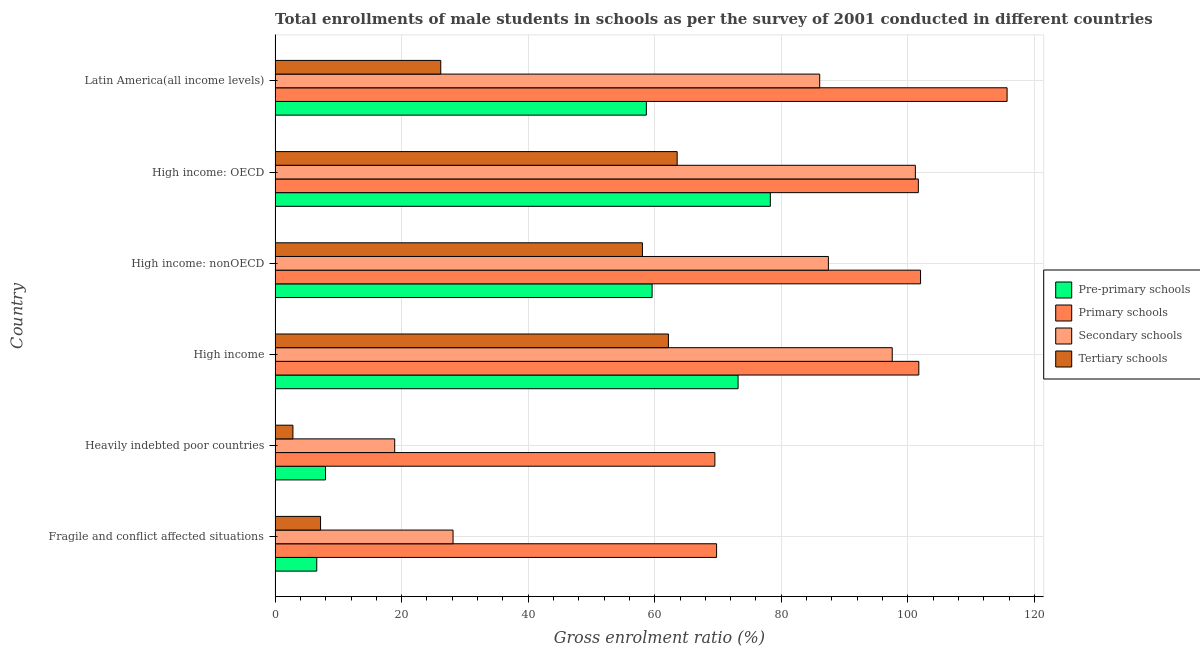How many groups of bars are there?
Provide a succinct answer. 6. Are the number of bars per tick equal to the number of legend labels?
Offer a very short reply. Yes. Are the number of bars on each tick of the Y-axis equal?
Keep it short and to the point. Yes. How many bars are there on the 5th tick from the top?
Offer a very short reply. 4. What is the label of the 5th group of bars from the top?
Keep it short and to the point. Heavily indebted poor countries. In how many cases, is the number of bars for a given country not equal to the number of legend labels?
Your response must be concise. 0. What is the gross enrolment ratio(male) in primary schools in High income?
Offer a terse response. 101.74. Across all countries, what is the maximum gross enrolment ratio(male) in secondary schools?
Give a very brief answer. 101.19. Across all countries, what is the minimum gross enrolment ratio(male) in secondary schools?
Your answer should be compact. 18.9. In which country was the gross enrolment ratio(male) in pre-primary schools maximum?
Offer a terse response. High income: OECD. In which country was the gross enrolment ratio(male) in secondary schools minimum?
Ensure brevity in your answer.  Heavily indebted poor countries. What is the total gross enrolment ratio(male) in secondary schools in the graph?
Offer a terse response. 419.28. What is the difference between the gross enrolment ratio(male) in secondary schools in Fragile and conflict affected situations and that in High income?
Keep it short and to the point. -69.41. What is the difference between the gross enrolment ratio(male) in secondary schools in High income: OECD and the gross enrolment ratio(male) in primary schools in High income: nonOECD?
Make the answer very short. -0.82. What is the average gross enrolment ratio(male) in primary schools per country?
Your answer should be compact. 93.4. What is the difference between the gross enrolment ratio(male) in pre-primary schools and gross enrolment ratio(male) in primary schools in High income: nonOECD?
Keep it short and to the point. -42.43. In how many countries, is the gross enrolment ratio(male) in pre-primary schools greater than 100 %?
Provide a succinct answer. 0. What is the ratio of the gross enrolment ratio(male) in tertiary schools in Heavily indebted poor countries to that in High income?
Your response must be concise. 0.04. What is the difference between the highest and the second highest gross enrolment ratio(male) in tertiary schools?
Make the answer very short. 1.38. What is the difference between the highest and the lowest gross enrolment ratio(male) in secondary schools?
Your answer should be compact. 82.28. In how many countries, is the gross enrolment ratio(male) in primary schools greater than the average gross enrolment ratio(male) in primary schools taken over all countries?
Your answer should be very brief. 4. Is the sum of the gross enrolment ratio(male) in pre-primary schools in High income: OECD and High income: nonOECD greater than the maximum gross enrolment ratio(male) in tertiary schools across all countries?
Provide a short and direct response. Yes. What does the 1st bar from the top in Fragile and conflict affected situations represents?
Your response must be concise. Tertiary schools. What does the 1st bar from the bottom in High income represents?
Offer a very short reply. Pre-primary schools. Is it the case that in every country, the sum of the gross enrolment ratio(male) in pre-primary schools and gross enrolment ratio(male) in primary schools is greater than the gross enrolment ratio(male) in secondary schools?
Offer a terse response. Yes. Are the values on the major ticks of X-axis written in scientific E-notation?
Ensure brevity in your answer.  No. Does the graph contain grids?
Your answer should be very brief. Yes. Where does the legend appear in the graph?
Provide a succinct answer. Center right. How many legend labels are there?
Your answer should be very brief. 4. How are the legend labels stacked?
Keep it short and to the point. Vertical. What is the title of the graph?
Offer a terse response. Total enrollments of male students in schools as per the survey of 2001 conducted in different countries. Does "Revenue mobilization" appear as one of the legend labels in the graph?
Offer a very short reply. No. What is the Gross enrolment ratio (%) of Pre-primary schools in Fragile and conflict affected situations?
Ensure brevity in your answer.  6.59. What is the Gross enrolment ratio (%) of Primary schools in Fragile and conflict affected situations?
Make the answer very short. 69.78. What is the Gross enrolment ratio (%) in Secondary schools in Fragile and conflict affected situations?
Offer a terse response. 28.13. What is the Gross enrolment ratio (%) of Tertiary schools in Fragile and conflict affected situations?
Your answer should be compact. 7.19. What is the Gross enrolment ratio (%) of Pre-primary schools in Heavily indebted poor countries?
Provide a succinct answer. 7.97. What is the Gross enrolment ratio (%) of Primary schools in Heavily indebted poor countries?
Offer a very short reply. 69.51. What is the Gross enrolment ratio (%) of Secondary schools in Heavily indebted poor countries?
Keep it short and to the point. 18.9. What is the Gross enrolment ratio (%) in Tertiary schools in Heavily indebted poor countries?
Your answer should be very brief. 2.82. What is the Gross enrolment ratio (%) in Pre-primary schools in High income?
Make the answer very short. 73.17. What is the Gross enrolment ratio (%) of Primary schools in High income?
Offer a terse response. 101.74. What is the Gross enrolment ratio (%) of Secondary schools in High income?
Your answer should be compact. 97.54. What is the Gross enrolment ratio (%) of Tertiary schools in High income?
Ensure brevity in your answer.  62.16. What is the Gross enrolment ratio (%) of Pre-primary schools in High income: nonOECD?
Offer a terse response. 59.59. What is the Gross enrolment ratio (%) in Primary schools in High income: nonOECD?
Offer a very short reply. 102.01. What is the Gross enrolment ratio (%) of Secondary schools in High income: nonOECD?
Provide a short and direct response. 87.44. What is the Gross enrolment ratio (%) of Tertiary schools in High income: nonOECD?
Your answer should be very brief. 58.06. What is the Gross enrolment ratio (%) in Pre-primary schools in High income: OECD?
Make the answer very short. 78.27. What is the Gross enrolment ratio (%) in Primary schools in High income: OECD?
Ensure brevity in your answer.  101.66. What is the Gross enrolment ratio (%) of Secondary schools in High income: OECD?
Offer a very short reply. 101.19. What is the Gross enrolment ratio (%) in Tertiary schools in High income: OECD?
Ensure brevity in your answer.  63.55. What is the Gross enrolment ratio (%) of Pre-primary schools in Latin America(all income levels)?
Your answer should be compact. 58.68. What is the Gross enrolment ratio (%) in Primary schools in Latin America(all income levels)?
Make the answer very short. 115.69. What is the Gross enrolment ratio (%) of Secondary schools in Latin America(all income levels)?
Ensure brevity in your answer.  86.07. What is the Gross enrolment ratio (%) in Tertiary schools in Latin America(all income levels)?
Your answer should be compact. 26.19. Across all countries, what is the maximum Gross enrolment ratio (%) in Pre-primary schools?
Keep it short and to the point. 78.27. Across all countries, what is the maximum Gross enrolment ratio (%) of Primary schools?
Offer a terse response. 115.69. Across all countries, what is the maximum Gross enrolment ratio (%) of Secondary schools?
Your answer should be compact. 101.19. Across all countries, what is the maximum Gross enrolment ratio (%) of Tertiary schools?
Offer a terse response. 63.55. Across all countries, what is the minimum Gross enrolment ratio (%) in Pre-primary schools?
Your response must be concise. 6.59. Across all countries, what is the minimum Gross enrolment ratio (%) in Primary schools?
Your answer should be very brief. 69.51. Across all countries, what is the minimum Gross enrolment ratio (%) of Secondary schools?
Your answer should be very brief. 18.9. Across all countries, what is the minimum Gross enrolment ratio (%) in Tertiary schools?
Provide a succinct answer. 2.82. What is the total Gross enrolment ratio (%) in Pre-primary schools in the graph?
Provide a short and direct response. 284.26. What is the total Gross enrolment ratio (%) in Primary schools in the graph?
Offer a very short reply. 560.38. What is the total Gross enrolment ratio (%) of Secondary schools in the graph?
Give a very brief answer. 419.28. What is the total Gross enrolment ratio (%) of Tertiary schools in the graph?
Offer a terse response. 219.96. What is the difference between the Gross enrolment ratio (%) of Pre-primary schools in Fragile and conflict affected situations and that in Heavily indebted poor countries?
Provide a succinct answer. -1.38. What is the difference between the Gross enrolment ratio (%) of Primary schools in Fragile and conflict affected situations and that in Heavily indebted poor countries?
Give a very brief answer. 0.27. What is the difference between the Gross enrolment ratio (%) of Secondary schools in Fragile and conflict affected situations and that in Heavily indebted poor countries?
Keep it short and to the point. 9.22. What is the difference between the Gross enrolment ratio (%) in Tertiary schools in Fragile and conflict affected situations and that in Heavily indebted poor countries?
Your answer should be very brief. 4.37. What is the difference between the Gross enrolment ratio (%) of Pre-primary schools in Fragile and conflict affected situations and that in High income?
Give a very brief answer. -66.59. What is the difference between the Gross enrolment ratio (%) in Primary schools in Fragile and conflict affected situations and that in High income?
Provide a succinct answer. -31.96. What is the difference between the Gross enrolment ratio (%) in Secondary schools in Fragile and conflict affected situations and that in High income?
Your answer should be compact. -69.41. What is the difference between the Gross enrolment ratio (%) of Tertiary schools in Fragile and conflict affected situations and that in High income?
Your response must be concise. -54.98. What is the difference between the Gross enrolment ratio (%) of Pre-primary schools in Fragile and conflict affected situations and that in High income: nonOECD?
Provide a short and direct response. -53. What is the difference between the Gross enrolment ratio (%) of Primary schools in Fragile and conflict affected situations and that in High income: nonOECD?
Keep it short and to the point. -32.24. What is the difference between the Gross enrolment ratio (%) of Secondary schools in Fragile and conflict affected situations and that in High income: nonOECD?
Give a very brief answer. -59.32. What is the difference between the Gross enrolment ratio (%) in Tertiary schools in Fragile and conflict affected situations and that in High income: nonOECD?
Ensure brevity in your answer.  -50.87. What is the difference between the Gross enrolment ratio (%) in Pre-primary schools in Fragile and conflict affected situations and that in High income: OECD?
Provide a short and direct response. -71.68. What is the difference between the Gross enrolment ratio (%) in Primary schools in Fragile and conflict affected situations and that in High income: OECD?
Your answer should be compact. -31.88. What is the difference between the Gross enrolment ratio (%) in Secondary schools in Fragile and conflict affected situations and that in High income: OECD?
Your response must be concise. -73.06. What is the difference between the Gross enrolment ratio (%) in Tertiary schools in Fragile and conflict affected situations and that in High income: OECD?
Your answer should be compact. -56.36. What is the difference between the Gross enrolment ratio (%) in Pre-primary schools in Fragile and conflict affected situations and that in Latin America(all income levels)?
Keep it short and to the point. -52.09. What is the difference between the Gross enrolment ratio (%) in Primary schools in Fragile and conflict affected situations and that in Latin America(all income levels)?
Make the answer very short. -45.91. What is the difference between the Gross enrolment ratio (%) of Secondary schools in Fragile and conflict affected situations and that in Latin America(all income levels)?
Your answer should be very brief. -57.95. What is the difference between the Gross enrolment ratio (%) in Tertiary schools in Fragile and conflict affected situations and that in Latin America(all income levels)?
Offer a very short reply. -19. What is the difference between the Gross enrolment ratio (%) of Pre-primary schools in Heavily indebted poor countries and that in High income?
Your answer should be very brief. -65.2. What is the difference between the Gross enrolment ratio (%) in Primary schools in Heavily indebted poor countries and that in High income?
Keep it short and to the point. -32.23. What is the difference between the Gross enrolment ratio (%) of Secondary schools in Heavily indebted poor countries and that in High income?
Your answer should be very brief. -78.63. What is the difference between the Gross enrolment ratio (%) of Tertiary schools in Heavily indebted poor countries and that in High income?
Give a very brief answer. -59.34. What is the difference between the Gross enrolment ratio (%) in Pre-primary schools in Heavily indebted poor countries and that in High income: nonOECD?
Make the answer very short. -51.62. What is the difference between the Gross enrolment ratio (%) in Primary schools in Heavily indebted poor countries and that in High income: nonOECD?
Ensure brevity in your answer.  -32.51. What is the difference between the Gross enrolment ratio (%) in Secondary schools in Heavily indebted poor countries and that in High income: nonOECD?
Offer a very short reply. -68.54. What is the difference between the Gross enrolment ratio (%) of Tertiary schools in Heavily indebted poor countries and that in High income: nonOECD?
Provide a succinct answer. -55.24. What is the difference between the Gross enrolment ratio (%) in Pre-primary schools in Heavily indebted poor countries and that in High income: OECD?
Ensure brevity in your answer.  -70.3. What is the difference between the Gross enrolment ratio (%) in Primary schools in Heavily indebted poor countries and that in High income: OECD?
Your response must be concise. -32.15. What is the difference between the Gross enrolment ratio (%) in Secondary schools in Heavily indebted poor countries and that in High income: OECD?
Make the answer very short. -82.28. What is the difference between the Gross enrolment ratio (%) of Tertiary schools in Heavily indebted poor countries and that in High income: OECD?
Offer a very short reply. -60.73. What is the difference between the Gross enrolment ratio (%) in Pre-primary schools in Heavily indebted poor countries and that in Latin America(all income levels)?
Provide a succinct answer. -50.71. What is the difference between the Gross enrolment ratio (%) of Primary schools in Heavily indebted poor countries and that in Latin America(all income levels)?
Your response must be concise. -46.18. What is the difference between the Gross enrolment ratio (%) of Secondary schools in Heavily indebted poor countries and that in Latin America(all income levels)?
Offer a terse response. -67.17. What is the difference between the Gross enrolment ratio (%) of Tertiary schools in Heavily indebted poor countries and that in Latin America(all income levels)?
Ensure brevity in your answer.  -23.37. What is the difference between the Gross enrolment ratio (%) in Pre-primary schools in High income and that in High income: nonOECD?
Offer a very short reply. 13.59. What is the difference between the Gross enrolment ratio (%) in Primary schools in High income and that in High income: nonOECD?
Provide a succinct answer. -0.28. What is the difference between the Gross enrolment ratio (%) of Secondary schools in High income and that in High income: nonOECD?
Keep it short and to the point. 10.09. What is the difference between the Gross enrolment ratio (%) of Tertiary schools in High income and that in High income: nonOECD?
Make the answer very short. 4.11. What is the difference between the Gross enrolment ratio (%) of Pre-primary schools in High income and that in High income: OECD?
Offer a very short reply. -5.1. What is the difference between the Gross enrolment ratio (%) of Primary schools in High income and that in High income: OECD?
Your answer should be very brief. 0.08. What is the difference between the Gross enrolment ratio (%) in Secondary schools in High income and that in High income: OECD?
Your response must be concise. -3.65. What is the difference between the Gross enrolment ratio (%) in Tertiary schools in High income and that in High income: OECD?
Your answer should be very brief. -1.38. What is the difference between the Gross enrolment ratio (%) of Pre-primary schools in High income and that in Latin America(all income levels)?
Your answer should be very brief. 14.5. What is the difference between the Gross enrolment ratio (%) of Primary schools in High income and that in Latin America(all income levels)?
Keep it short and to the point. -13.95. What is the difference between the Gross enrolment ratio (%) of Secondary schools in High income and that in Latin America(all income levels)?
Offer a very short reply. 11.46. What is the difference between the Gross enrolment ratio (%) in Tertiary schools in High income and that in Latin America(all income levels)?
Ensure brevity in your answer.  35.98. What is the difference between the Gross enrolment ratio (%) in Pre-primary schools in High income: nonOECD and that in High income: OECD?
Your answer should be very brief. -18.68. What is the difference between the Gross enrolment ratio (%) of Primary schools in High income: nonOECD and that in High income: OECD?
Keep it short and to the point. 0.35. What is the difference between the Gross enrolment ratio (%) of Secondary schools in High income: nonOECD and that in High income: OECD?
Ensure brevity in your answer.  -13.75. What is the difference between the Gross enrolment ratio (%) in Tertiary schools in High income: nonOECD and that in High income: OECD?
Give a very brief answer. -5.49. What is the difference between the Gross enrolment ratio (%) in Pre-primary schools in High income: nonOECD and that in Latin America(all income levels)?
Make the answer very short. 0.91. What is the difference between the Gross enrolment ratio (%) in Primary schools in High income: nonOECD and that in Latin America(all income levels)?
Your answer should be compact. -13.68. What is the difference between the Gross enrolment ratio (%) in Secondary schools in High income: nonOECD and that in Latin America(all income levels)?
Offer a terse response. 1.37. What is the difference between the Gross enrolment ratio (%) of Tertiary schools in High income: nonOECD and that in Latin America(all income levels)?
Offer a very short reply. 31.87. What is the difference between the Gross enrolment ratio (%) in Pre-primary schools in High income: OECD and that in Latin America(all income levels)?
Provide a succinct answer. 19.59. What is the difference between the Gross enrolment ratio (%) in Primary schools in High income: OECD and that in Latin America(all income levels)?
Provide a short and direct response. -14.03. What is the difference between the Gross enrolment ratio (%) of Secondary schools in High income: OECD and that in Latin America(all income levels)?
Give a very brief answer. 15.12. What is the difference between the Gross enrolment ratio (%) of Tertiary schools in High income: OECD and that in Latin America(all income levels)?
Keep it short and to the point. 37.36. What is the difference between the Gross enrolment ratio (%) in Pre-primary schools in Fragile and conflict affected situations and the Gross enrolment ratio (%) in Primary schools in Heavily indebted poor countries?
Offer a very short reply. -62.92. What is the difference between the Gross enrolment ratio (%) of Pre-primary schools in Fragile and conflict affected situations and the Gross enrolment ratio (%) of Secondary schools in Heavily indebted poor countries?
Ensure brevity in your answer.  -12.32. What is the difference between the Gross enrolment ratio (%) of Pre-primary schools in Fragile and conflict affected situations and the Gross enrolment ratio (%) of Tertiary schools in Heavily indebted poor countries?
Your answer should be very brief. 3.77. What is the difference between the Gross enrolment ratio (%) in Primary schools in Fragile and conflict affected situations and the Gross enrolment ratio (%) in Secondary schools in Heavily indebted poor countries?
Offer a very short reply. 50.87. What is the difference between the Gross enrolment ratio (%) of Primary schools in Fragile and conflict affected situations and the Gross enrolment ratio (%) of Tertiary schools in Heavily indebted poor countries?
Ensure brevity in your answer.  66.96. What is the difference between the Gross enrolment ratio (%) in Secondary schools in Fragile and conflict affected situations and the Gross enrolment ratio (%) in Tertiary schools in Heavily indebted poor countries?
Give a very brief answer. 25.31. What is the difference between the Gross enrolment ratio (%) in Pre-primary schools in Fragile and conflict affected situations and the Gross enrolment ratio (%) in Primary schools in High income?
Keep it short and to the point. -95.15. What is the difference between the Gross enrolment ratio (%) of Pre-primary schools in Fragile and conflict affected situations and the Gross enrolment ratio (%) of Secondary schools in High income?
Your response must be concise. -90.95. What is the difference between the Gross enrolment ratio (%) of Pre-primary schools in Fragile and conflict affected situations and the Gross enrolment ratio (%) of Tertiary schools in High income?
Your answer should be compact. -55.58. What is the difference between the Gross enrolment ratio (%) of Primary schools in Fragile and conflict affected situations and the Gross enrolment ratio (%) of Secondary schools in High income?
Offer a terse response. -27.76. What is the difference between the Gross enrolment ratio (%) in Primary schools in Fragile and conflict affected situations and the Gross enrolment ratio (%) in Tertiary schools in High income?
Offer a terse response. 7.61. What is the difference between the Gross enrolment ratio (%) of Secondary schools in Fragile and conflict affected situations and the Gross enrolment ratio (%) of Tertiary schools in High income?
Offer a very short reply. -34.04. What is the difference between the Gross enrolment ratio (%) in Pre-primary schools in Fragile and conflict affected situations and the Gross enrolment ratio (%) in Primary schools in High income: nonOECD?
Ensure brevity in your answer.  -95.43. What is the difference between the Gross enrolment ratio (%) in Pre-primary schools in Fragile and conflict affected situations and the Gross enrolment ratio (%) in Secondary schools in High income: nonOECD?
Make the answer very short. -80.86. What is the difference between the Gross enrolment ratio (%) in Pre-primary schools in Fragile and conflict affected situations and the Gross enrolment ratio (%) in Tertiary schools in High income: nonOECD?
Make the answer very short. -51.47. What is the difference between the Gross enrolment ratio (%) in Primary schools in Fragile and conflict affected situations and the Gross enrolment ratio (%) in Secondary schools in High income: nonOECD?
Give a very brief answer. -17.67. What is the difference between the Gross enrolment ratio (%) in Primary schools in Fragile and conflict affected situations and the Gross enrolment ratio (%) in Tertiary schools in High income: nonOECD?
Provide a short and direct response. 11.72. What is the difference between the Gross enrolment ratio (%) in Secondary schools in Fragile and conflict affected situations and the Gross enrolment ratio (%) in Tertiary schools in High income: nonOECD?
Ensure brevity in your answer.  -29.93. What is the difference between the Gross enrolment ratio (%) of Pre-primary schools in Fragile and conflict affected situations and the Gross enrolment ratio (%) of Primary schools in High income: OECD?
Your answer should be very brief. -95.07. What is the difference between the Gross enrolment ratio (%) of Pre-primary schools in Fragile and conflict affected situations and the Gross enrolment ratio (%) of Secondary schools in High income: OECD?
Give a very brief answer. -94.6. What is the difference between the Gross enrolment ratio (%) in Pre-primary schools in Fragile and conflict affected situations and the Gross enrolment ratio (%) in Tertiary schools in High income: OECD?
Make the answer very short. -56.96. What is the difference between the Gross enrolment ratio (%) of Primary schools in Fragile and conflict affected situations and the Gross enrolment ratio (%) of Secondary schools in High income: OECD?
Ensure brevity in your answer.  -31.41. What is the difference between the Gross enrolment ratio (%) in Primary schools in Fragile and conflict affected situations and the Gross enrolment ratio (%) in Tertiary schools in High income: OECD?
Offer a very short reply. 6.23. What is the difference between the Gross enrolment ratio (%) of Secondary schools in Fragile and conflict affected situations and the Gross enrolment ratio (%) of Tertiary schools in High income: OECD?
Keep it short and to the point. -35.42. What is the difference between the Gross enrolment ratio (%) of Pre-primary schools in Fragile and conflict affected situations and the Gross enrolment ratio (%) of Primary schools in Latin America(all income levels)?
Your answer should be very brief. -109.1. What is the difference between the Gross enrolment ratio (%) in Pre-primary schools in Fragile and conflict affected situations and the Gross enrolment ratio (%) in Secondary schools in Latin America(all income levels)?
Offer a terse response. -79.49. What is the difference between the Gross enrolment ratio (%) of Pre-primary schools in Fragile and conflict affected situations and the Gross enrolment ratio (%) of Tertiary schools in Latin America(all income levels)?
Give a very brief answer. -19.6. What is the difference between the Gross enrolment ratio (%) of Primary schools in Fragile and conflict affected situations and the Gross enrolment ratio (%) of Secondary schools in Latin America(all income levels)?
Ensure brevity in your answer.  -16.3. What is the difference between the Gross enrolment ratio (%) of Primary schools in Fragile and conflict affected situations and the Gross enrolment ratio (%) of Tertiary schools in Latin America(all income levels)?
Your answer should be compact. 43.59. What is the difference between the Gross enrolment ratio (%) in Secondary schools in Fragile and conflict affected situations and the Gross enrolment ratio (%) in Tertiary schools in Latin America(all income levels)?
Your response must be concise. 1.94. What is the difference between the Gross enrolment ratio (%) of Pre-primary schools in Heavily indebted poor countries and the Gross enrolment ratio (%) of Primary schools in High income?
Your answer should be very brief. -93.77. What is the difference between the Gross enrolment ratio (%) of Pre-primary schools in Heavily indebted poor countries and the Gross enrolment ratio (%) of Secondary schools in High income?
Your answer should be very brief. -89.57. What is the difference between the Gross enrolment ratio (%) of Pre-primary schools in Heavily indebted poor countries and the Gross enrolment ratio (%) of Tertiary schools in High income?
Your answer should be compact. -54.2. What is the difference between the Gross enrolment ratio (%) in Primary schools in Heavily indebted poor countries and the Gross enrolment ratio (%) in Secondary schools in High income?
Provide a short and direct response. -28.03. What is the difference between the Gross enrolment ratio (%) of Primary schools in Heavily indebted poor countries and the Gross enrolment ratio (%) of Tertiary schools in High income?
Make the answer very short. 7.34. What is the difference between the Gross enrolment ratio (%) in Secondary schools in Heavily indebted poor countries and the Gross enrolment ratio (%) in Tertiary schools in High income?
Offer a very short reply. -43.26. What is the difference between the Gross enrolment ratio (%) of Pre-primary schools in Heavily indebted poor countries and the Gross enrolment ratio (%) of Primary schools in High income: nonOECD?
Keep it short and to the point. -94.04. What is the difference between the Gross enrolment ratio (%) in Pre-primary schools in Heavily indebted poor countries and the Gross enrolment ratio (%) in Secondary schools in High income: nonOECD?
Your answer should be compact. -79.48. What is the difference between the Gross enrolment ratio (%) in Pre-primary schools in Heavily indebted poor countries and the Gross enrolment ratio (%) in Tertiary schools in High income: nonOECD?
Ensure brevity in your answer.  -50.09. What is the difference between the Gross enrolment ratio (%) in Primary schools in Heavily indebted poor countries and the Gross enrolment ratio (%) in Secondary schools in High income: nonOECD?
Keep it short and to the point. -17.94. What is the difference between the Gross enrolment ratio (%) in Primary schools in Heavily indebted poor countries and the Gross enrolment ratio (%) in Tertiary schools in High income: nonOECD?
Your response must be concise. 11.45. What is the difference between the Gross enrolment ratio (%) of Secondary schools in Heavily indebted poor countries and the Gross enrolment ratio (%) of Tertiary schools in High income: nonOECD?
Your answer should be compact. -39.15. What is the difference between the Gross enrolment ratio (%) of Pre-primary schools in Heavily indebted poor countries and the Gross enrolment ratio (%) of Primary schools in High income: OECD?
Your answer should be compact. -93.69. What is the difference between the Gross enrolment ratio (%) of Pre-primary schools in Heavily indebted poor countries and the Gross enrolment ratio (%) of Secondary schools in High income: OECD?
Ensure brevity in your answer.  -93.22. What is the difference between the Gross enrolment ratio (%) in Pre-primary schools in Heavily indebted poor countries and the Gross enrolment ratio (%) in Tertiary schools in High income: OECD?
Offer a very short reply. -55.58. What is the difference between the Gross enrolment ratio (%) in Primary schools in Heavily indebted poor countries and the Gross enrolment ratio (%) in Secondary schools in High income: OECD?
Keep it short and to the point. -31.68. What is the difference between the Gross enrolment ratio (%) in Primary schools in Heavily indebted poor countries and the Gross enrolment ratio (%) in Tertiary schools in High income: OECD?
Make the answer very short. 5.96. What is the difference between the Gross enrolment ratio (%) of Secondary schools in Heavily indebted poor countries and the Gross enrolment ratio (%) of Tertiary schools in High income: OECD?
Ensure brevity in your answer.  -44.64. What is the difference between the Gross enrolment ratio (%) of Pre-primary schools in Heavily indebted poor countries and the Gross enrolment ratio (%) of Primary schools in Latin America(all income levels)?
Your response must be concise. -107.72. What is the difference between the Gross enrolment ratio (%) in Pre-primary schools in Heavily indebted poor countries and the Gross enrolment ratio (%) in Secondary schools in Latin America(all income levels)?
Provide a succinct answer. -78.11. What is the difference between the Gross enrolment ratio (%) in Pre-primary schools in Heavily indebted poor countries and the Gross enrolment ratio (%) in Tertiary schools in Latin America(all income levels)?
Provide a succinct answer. -18.22. What is the difference between the Gross enrolment ratio (%) in Primary schools in Heavily indebted poor countries and the Gross enrolment ratio (%) in Secondary schools in Latin America(all income levels)?
Give a very brief answer. -16.57. What is the difference between the Gross enrolment ratio (%) of Primary schools in Heavily indebted poor countries and the Gross enrolment ratio (%) of Tertiary schools in Latin America(all income levels)?
Offer a very short reply. 43.32. What is the difference between the Gross enrolment ratio (%) of Secondary schools in Heavily indebted poor countries and the Gross enrolment ratio (%) of Tertiary schools in Latin America(all income levels)?
Make the answer very short. -7.28. What is the difference between the Gross enrolment ratio (%) in Pre-primary schools in High income and the Gross enrolment ratio (%) in Primary schools in High income: nonOECD?
Your answer should be compact. -28.84. What is the difference between the Gross enrolment ratio (%) in Pre-primary schools in High income and the Gross enrolment ratio (%) in Secondary schools in High income: nonOECD?
Your answer should be very brief. -14.27. What is the difference between the Gross enrolment ratio (%) in Pre-primary schools in High income and the Gross enrolment ratio (%) in Tertiary schools in High income: nonOECD?
Offer a very short reply. 15.12. What is the difference between the Gross enrolment ratio (%) in Primary schools in High income and the Gross enrolment ratio (%) in Secondary schools in High income: nonOECD?
Provide a succinct answer. 14.29. What is the difference between the Gross enrolment ratio (%) of Primary schools in High income and the Gross enrolment ratio (%) of Tertiary schools in High income: nonOECD?
Your response must be concise. 43.68. What is the difference between the Gross enrolment ratio (%) in Secondary schools in High income and the Gross enrolment ratio (%) in Tertiary schools in High income: nonOECD?
Provide a succinct answer. 39.48. What is the difference between the Gross enrolment ratio (%) in Pre-primary schools in High income and the Gross enrolment ratio (%) in Primary schools in High income: OECD?
Provide a succinct answer. -28.49. What is the difference between the Gross enrolment ratio (%) in Pre-primary schools in High income and the Gross enrolment ratio (%) in Secondary schools in High income: OECD?
Provide a succinct answer. -28.02. What is the difference between the Gross enrolment ratio (%) in Pre-primary schools in High income and the Gross enrolment ratio (%) in Tertiary schools in High income: OECD?
Offer a terse response. 9.62. What is the difference between the Gross enrolment ratio (%) of Primary schools in High income and the Gross enrolment ratio (%) of Secondary schools in High income: OECD?
Your answer should be compact. 0.55. What is the difference between the Gross enrolment ratio (%) in Primary schools in High income and the Gross enrolment ratio (%) in Tertiary schools in High income: OECD?
Make the answer very short. 38.19. What is the difference between the Gross enrolment ratio (%) in Secondary schools in High income and the Gross enrolment ratio (%) in Tertiary schools in High income: OECD?
Ensure brevity in your answer.  33.99. What is the difference between the Gross enrolment ratio (%) in Pre-primary schools in High income and the Gross enrolment ratio (%) in Primary schools in Latin America(all income levels)?
Offer a terse response. -42.52. What is the difference between the Gross enrolment ratio (%) of Pre-primary schools in High income and the Gross enrolment ratio (%) of Secondary schools in Latin America(all income levels)?
Your answer should be compact. -12.9. What is the difference between the Gross enrolment ratio (%) in Pre-primary schools in High income and the Gross enrolment ratio (%) in Tertiary schools in Latin America(all income levels)?
Make the answer very short. 46.99. What is the difference between the Gross enrolment ratio (%) in Primary schools in High income and the Gross enrolment ratio (%) in Secondary schools in Latin America(all income levels)?
Keep it short and to the point. 15.66. What is the difference between the Gross enrolment ratio (%) in Primary schools in High income and the Gross enrolment ratio (%) in Tertiary schools in Latin America(all income levels)?
Your answer should be very brief. 75.55. What is the difference between the Gross enrolment ratio (%) in Secondary schools in High income and the Gross enrolment ratio (%) in Tertiary schools in Latin America(all income levels)?
Give a very brief answer. 71.35. What is the difference between the Gross enrolment ratio (%) in Pre-primary schools in High income: nonOECD and the Gross enrolment ratio (%) in Primary schools in High income: OECD?
Offer a very short reply. -42.07. What is the difference between the Gross enrolment ratio (%) of Pre-primary schools in High income: nonOECD and the Gross enrolment ratio (%) of Secondary schools in High income: OECD?
Your response must be concise. -41.6. What is the difference between the Gross enrolment ratio (%) of Pre-primary schools in High income: nonOECD and the Gross enrolment ratio (%) of Tertiary schools in High income: OECD?
Offer a terse response. -3.96. What is the difference between the Gross enrolment ratio (%) in Primary schools in High income: nonOECD and the Gross enrolment ratio (%) in Secondary schools in High income: OECD?
Give a very brief answer. 0.82. What is the difference between the Gross enrolment ratio (%) of Primary schools in High income: nonOECD and the Gross enrolment ratio (%) of Tertiary schools in High income: OECD?
Your answer should be compact. 38.46. What is the difference between the Gross enrolment ratio (%) of Secondary schools in High income: nonOECD and the Gross enrolment ratio (%) of Tertiary schools in High income: OECD?
Ensure brevity in your answer.  23.9. What is the difference between the Gross enrolment ratio (%) in Pre-primary schools in High income: nonOECD and the Gross enrolment ratio (%) in Primary schools in Latin America(all income levels)?
Provide a short and direct response. -56.1. What is the difference between the Gross enrolment ratio (%) in Pre-primary schools in High income: nonOECD and the Gross enrolment ratio (%) in Secondary schools in Latin America(all income levels)?
Offer a terse response. -26.49. What is the difference between the Gross enrolment ratio (%) of Pre-primary schools in High income: nonOECD and the Gross enrolment ratio (%) of Tertiary schools in Latin America(all income levels)?
Ensure brevity in your answer.  33.4. What is the difference between the Gross enrolment ratio (%) of Primary schools in High income: nonOECD and the Gross enrolment ratio (%) of Secondary schools in Latin America(all income levels)?
Ensure brevity in your answer.  15.94. What is the difference between the Gross enrolment ratio (%) of Primary schools in High income: nonOECD and the Gross enrolment ratio (%) of Tertiary schools in Latin America(all income levels)?
Your response must be concise. 75.83. What is the difference between the Gross enrolment ratio (%) in Secondary schools in High income: nonOECD and the Gross enrolment ratio (%) in Tertiary schools in Latin America(all income levels)?
Offer a very short reply. 61.26. What is the difference between the Gross enrolment ratio (%) in Pre-primary schools in High income: OECD and the Gross enrolment ratio (%) in Primary schools in Latin America(all income levels)?
Your answer should be compact. -37.42. What is the difference between the Gross enrolment ratio (%) of Pre-primary schools in High income: OECD and the Gross enrolment ratio (%) of Secondary schools in Latin America(all income levels)?
Offer a terse response. -7.81. What is the difference between the Gross enrolment ratio (%) of Pre-primary schools in High income: OECD and the Gross enrolment ratio (%) of Tertiary schools in Latin America(all income levels)?
Make the answer very short. 52.08. What is the difference between the Gross enrolment ratio (%) in Primary schools in High income: OECD and the Gross enrolment ratio (%) in Secondary schools in Latin America(all income levels)?
Offer a very short reply. 15.59. What is the difference between the Gross enrolment ratio (%) in Primary schools in High income: OECD and the Gross enrolment ratio (%) in Tertiary schools in Latin America(all income levels)?
Your response must be concise. 75.48. What is the difference between the Gross enrolment ratio (%) of Secondary schools in High income: OECD and the Gross enrolment ratio (%) of Tertiary schools in Latin America(all income levels)?
Ensure brevity in your answer.  75. What is the average Gross enrolment ratio (%) in Pre-primary schools per country?
Your answer should be very brief. 47.38. What is the average Gross enrolment ratio (%) of Primary schools per country?
Offer a very short reply. 93.4. What is the average Gross enrolment ratio (%) of Secondary schools per country?
Make the answer very short. 69.88. What is the average Gross enrolment ratio (%) in Tertiary schools per country?
Your answer should be very brief. 36.66. What is the difference between the Gross enrolment ratio (%) in Pre-primary schools and Gross enrolment ratio (%) in Primary schools in Fragile and conflict affected situations?
Provide a short and direct response. -63.19. What is the difference between the Gross enrolment ratio (%) in Pre-primary schools and Gross enrolment ratio (%) in Secondary schools in Fragile and conflict affected situations?
Your answer should be very brief. -21.54. What is the difference between the Gross enrolment ratio (%) of Pre-primary schools and Gross enrolment ratio (%) of Tertiary schools in Fragile and conflict affected situations?
Offer a very short reply. -0.6. What is the difference between the Gross enrolment ratio (%) in Primary schools and Gross enrolment ratio (%) in Secondary schools in Fragile and conflict affected situations?
Your answer should be very brief. 41.65. What is the difference between the Gross enrolment ratio (%) in Primary schools and Gross enrolment ratio (%) in Tertiary schools in Fragile and conflict affected situations?
Offer a terse response. 62.59. What is the difference between the Gross enrolment ratio (%) of Secondary schools and Gross enrolment ratio (%) of Tertiary schools in Fragile and conflict affected situations?
Provide a succinct answer. 20.94. What is the difference between the Gross enrolment ratio (%) in Pre-primary schools and Gross enrolment ratio (%) in Primary schools in Heavily indebted poor countries?
Provide a succinct answer. -61.54. What is the difference between the Gross enrolment ratio (%) of Pre-primary schools and Gross enrolment ratio (%) of Secondary schools in Heavily indebted poor countries?
Provide a succinct answer. -10.94. What is the difference between the Gross enrolment ratio (%) in Pre-primary schools and Gross enrolment ratio (%) in Tertiary schools in Heavily indebted poor countries?
Give a very brief answer. 5.15. What is the difference between the Gross enrolment ratio (%) in Primary schools and Gross enrolment ratio (%) in Secondary schools in Heavily indebted poor countries?
Make the answer very short. 50.6. What is the difference between the Gross enrolment ratio (%) of Primary schools and Gross enrolment ratio (%) of Tertiary schools in Heavily indebted poor countries?
Offer a very short reply. 66.69. What is the difference between the Gross enrolment ratio (%) of Secondary schools and Gross enrolment ratio (%) of Tertiary schools in Heavily indebted poor countries?
Your answer should be compact. 16.09. What is the difference between the Gross enrolment ratio (%) of Pre-primary schools and Gross enrolment ratio (%) of Primary schools in High income?
Your answer should be compact. -28.56. What is the difference between the Gross enrolment ratio (%) in Pre-primary schools and Gross enrolment ratio (%) in Secondary schools in High income?
Your answer should be compact. -24.36. What is the difference between the Gross enrolment ratio (%) in Pre-primary schools and Gross enrolment ratio (%) in Tertiary schools in High income?
Offer a terse response. 11.01. What is the difference between the Gross enrolment ratio (%) in Primary schools and Gross enrolment ratio (%) in Tertiary schools in High income?
Provide a succinct answer. 39.57. What is the difference between the Gross enrolment ratio (%) in Secondary schools and Gross enrolment ratio (%) in Tertiary schools in High income?
Your answer should be compact. 35.37. What is the difference between the Gross enrolment ratio (%) of Pre-primary schools and Gross enrolment ratio (%) of Primary schools in High income: nonOECD?
Offer a terse response. -42.43. What is the difference between the Gross enrolment ratio (%) in Pre-primary schools and Gross enrolment ratio (%) in Secondary schools in High income: nonOECD?
Give a very brief answer. -27.86. What is the difference between the Gross enrolment ratio (%) of Pre-primary schools and Gross enrolment ratio (%) of Tertiary schools in High income: nonOECD?
Offer a very short reply. 1.53. What is the difference between the Gross enrolment ratio (%) in Primary schools and Gross enrolment ratio (%) in Secondary schools in High income: nonOECD?
Offer a very short reply. 14.57. What is the difference between the Gross enrolment ratio (%) of Primary schools and Gross enrolment ratio (%) of Tertiary schools in High income: nonOECD?
Make the answer very short. 43.96. What is the difference between the Gross enrolment ratio (%) in Secondary schools and Gross enrolment ratio (%) in Tertiary schools in High income: nonOECD?
Offer a very short reply. 29.39. What is the difference between the Gross enrolment ratio (%) of Pre-primary schools and Gross enrolment ratio (%) of Primary schools in High income: OECD?
Offer a very short reply. -23.39. What is the difference between the Gross enrolment ratio (%) of Pre-primary schools and Gross enrolment ratio (%) of Secondary schools in High income: OECD?
Offer a very short reply. -22.92. What is the difference between the Gross enrolment ratio (%) in Pre-primary schools and Gross enrolment ratio (%) in Tertiary schools in High income: OECD?
Offer a terse response. 14.72. What is the difference between the Gross enrolment ratio (%) in Primary schools and Gross enrolment ratio (%) in Secondary schools in High income: OECD?
Provide a succinct answer. 0.47. What is the difference between the Gross enrolment ratio (%) of Primary schools and Gross enrolment ratio (%) of Tertiary schools in High income: OECD?
Provide a succinct answer. 38.11. What is the difference between the Gross enrolment ratio (%) of Secondary schools and Gross enrolment ratio (%) of Tertiary schools in High income: OECD?
Ensure brevity in your answer.  37.64. What is the difference between the Gross enrolment ratio (%) of Pre-primary schools and Gross enrolment ratio (%) of Primary schools in Latin America(all income levels)?
Your response must be concise. -57.01. What is the difference between the Gross enrolment ratio (%) in Pre-primary schools and Gross enrolment ratio (%) in Secondary schools in Latin America(all income levels)?
Provide a succinct answer. -27.4. What is the difference between the Gross enrolment ratio (%) in Pre-primary schools and Gross enrolment ratio (%) in Tertiary schools in Latin America(all income levels)?
Your answer should be compact. 32.49. What is the difference between the Gross enrolment ratio (%) of Primary schools and Gross enrolment ratio (%) of Secondary schools in Latin America(all income levels)?
Make the answer very short. 29.61. What is the difference between the Gross enrolment ratio (%) of Primary schools and Gross enrolment ratio (%) of Tertiary schools in Latin America(all income levels)?
Provide a succinct answer. 89.5. What is the difference between the Gross enrolment ratio (%) of Secondary schools and Gross enrolment ratio (%) of Tertiary schools in Latin America(all income levels)?
Provide a succinct answer. 59.89. What is the ratio of the Gross enrolment ratio (%) in Pre-primary schools in Fragile and conflict affected situations to that in Heavily indebted poor countries?
Keep it short and to the point. 0.83. What is the ratio of the Gross enrolment ratio (%) in Secondary schools in Fragile and conflict affected situations to that in Heavily indebted poor countries?
Give a very brief answer. 1.49. What is the ratio of the Gross enrolment ratio (%) of Tertiary schools in Fragile and conflict affected situations to that in Heavily indebted poor countries?
Your answer should be compact. 2.55. What is the ratio of the Gross enrolment ratio (%) in Pre-primary schools in Fragile and conflict affected situations to that in High income?
Your answer should be compact. 0.09. What is the ratio of the Gross enrolment ratio (%) of Primary schools in Fragile and conflict affected situations to that in High income?
Keep it short and to the point. 0.69. What is the ratio of the Gross enrolment ratio (%) in Secondary schools in Fragile and conflict affected situations to that in High income?
Your response must be concise. 0.29. What is the ratio of the Gross enrolment ratio (%) in Tertiary schools in Fragile and conflict affected situations to that in High income?
Provide a short and direct response. 0.12. What is the ratio of the Gross enrolment ratio (%) of Pre-primary schools in Fragile and conflict affected situations to that in High income: nonOECD?
Your answer should be compact. 0.11. What is the ratio of the Gross enrolment ratio (%) of Primary schools in Fragile and conflict affected situations to that in High income: nonOECD?
Your response must be concise. 0.68. What is the ratio of the Gross enrolment ratio (%) of Secondary schools in Fragile and conflict affected situations to that in High income: nonOECD?
Give a very brief answer. 0.32. What is the ratio of the Gross enrolment ratio (%) in Tertiary schools in Fragile and conflict affected situations to that in High income: nonOECD?
Offer a very short reply. 0.12. What is the ratio of the Gross enrolment ratio (%) in Pre-primary schools in Fragile and conflict affected situations to that in High income: OECD?
Ensure brevity in your answer.  0.08. What is the ratio of the Gross enrolment ratio (%) in Primary schools in Fragile and conflict affected situations to that in High income: OECD?
Provide a succinct answer. 0.69. What is the ratio of the Gross enrolment ratio (%) of Secondary schools in Fragile and conflict affected situations to that in High income: OECD?
Keep it short and to the point. 0.28. What is the ratio of the Gross enrolment ratio (%) of Tertiary schools in Fragile and conflict affected situations to that in High income: OECD?
Keep it short and to the point. 0.11. What is the ratio of the Gross enrolment ratio (%) in Pre-primary schools in Fragile and conflict affected situations to that in Latin America(all income levels)?
Give a very brief answer. 0.11. What is the ratio of the Gross enrolment ratio (%) of Primary schools in Fragile and conflict affected situations to that in Latin America(all income levels)?
Your answer should be compact. 0.6. What is the ratio of the Gross enrolment ratio (%) in Secondary schools in Fragile and conflict affected situations to that in Latin America(all income levels)?
Ensure brevity in your answer.  0.33. What is the ratio of the Gross enrolment ratio (%) in Tertiary schools in Fragile and conflict affected situations to that in Latin America(all income levels)?
Your response must be concise. 0.27. What is the ratio of the Gross enrolment ratio (%) in Pre-primary schools in Heavily indebted poor countries to that in High income?
Offer a very short reply. 0.11. What is the ratio of the Gross enrolment ratio (%) in Primary schools in Heavily indebted poor countries to that in High income?
Offer a very short reply. 0.68. What is the ratio of the Gross enrolment ratio (%) of Secondary schools in Heavily indebted poor countries to that in High income?
Your answer should be compact. 0.19. What is the ratio of the Gross enrolment ratio (%) in Tertiary schools in Heavily indebted poor countries to that in High income?
Ensure brevity in your answer.  0.05. What is the ratio of the Gross enrolment ratio (%) in Pre-primary schools in Heavily indebted poor countries to that in High income: nonOECD?
Provide a succinct answer. 0.13. What is the ratio of the Gross enrolment ratio (%) of Primary schools in Heavily indebted poor countries to that in High income: nonOECD?
Provide a short and direct response. 0.68. What is the ratio of the Gross enrolment ratio (%) in Secondary schools in Heavily indebted poor countries to that in High income: nonOECD?
Your response must be concise. 0.22. What is the ratio of the Gross enrolment ratio (%) of Tertiary schools in Heavily indebted poor countries to that in High income: nonOECD?
Provide a short and direct response. 0.05. What is the ratio of the Gross enrolment ratio (%) in Pre-primary schools in Heavily indebted poor countries to that in High income: OECD?
Your answer should be compact. 0.1. What is the ratio of the Gross enrolment ratio (%) in Primary schools in Heavily indebted poor countries to that in High income: OECD?
Offer a very short reply. 0.68. What is the ratio of the Gross enrolment ratio (%) of Secondary schools in Heavily indebted poor countries to that in High income: OECD?
Provide a succinct answer. 0.19. What is the ratio of the Gross enrolment ratio (%) in Tertiary schools in Heavily indebted poor countries to that in High income: OECD?
Offer a terse response. 0.04. What is the ratio of the Gross enrolment ratio (%) of Pre-primary schools in Heavily indebted poor countries to that in Latin America(all income levels)?
Your answer should be very brief. 0.14. What is the ratio of the Gross enrolment ratio (%) of Primary schools in Heavily indebted poor countries to that in Latin America(all income levels)?
Provide a succinct answer. 0.6. What is the ratio of the Gross enrolment ratio (%) in Secondary schools in Heavily indebted poor countries to that in Latin America(all income levels)?
Keep it short and to the point. 0.22. What is the ratio of the Gross enrolment ratio (%) in Tertiary schools in Heavily indebted poor countries to that in Latin America(all income levels)?
Offer a terse response. 0.11. What is the ratio of the Gross enrolment ratio (%) in Pre-primary schools in High income to that in High income: nonOECD?
Offer a very short reply. 1.23. What is the ratio of the Gross enrolment ratio (%) in Primary schools in High income to that in High income: nonOECD?
Keep it short and to the point. 1. What is the ratio of the Gross enrolment ratio (%) in Secondary schools in High income to that in High income: nonOECD?
Your answer should be very brief. 1.12. What is the ratio of the Gross enrolment ratio (%) of Tertiary schools in High income to that in High income: nonOECD?
Keep it short and to the point. 1.07. What is the ratio of the Gross enrolment ratio (%) in Pre-primary schools in High income to that in High income: OECD?
Make the answer very short. 0.93. What is the ratio of the Gross enrolment ratio (%) of Secondary schools in High income to that in High income: OECD?
Ensure brevity in your answer.  0.96. What is the ratio of the Gross enrolment ratio (%) of Tertiary schools in High income to that in High income: OECD?
Provide a succinct answer. 0.98. What is the ratio of the Gross enrolment ratio (%) of Pre-primary schools in High income to that in Latin America(all income levels)?
Your answer should be compact. 1.25. What is the ratio of the Gross enrolment ratio (%) in Primary schools in High income to that in Latin America(all income levels)?
Ensure brevity in your answer.  0.88. What is the ratio of the Gross enrolment ratio (%) of Secondary schools in High income to that in Latin America(all income levels)?
Your answer should be very brief. 1.13. What is the ratio of the Gross enrolment ratio (%) of Tertiary schools in High income to that in Latin America(all income levels)?
Make the answer very short. 2.37. What is the ratio of the Gross enrolment ratio (%) of Pre-primary schools in High income: nonOECD to that in High income: OECD?
Keep it short and to the point. 0.76. What is the ratio of the Gross enrolment ratio (%) in Secondary schools in High income: nonOECD to that in High income: OECD?
Provide a short and direct response. 0.86. What is the ratio of the Gross enrolment ratio (%) of Tertiary schools in High income: nonOECD to that in High income: OECD?
Your answer should be very brief. 0.91. What is the ratio of the Gross enrolment ratio (%) of Pre-primary schools in High income: nonOECD to that in Latin America(all income levels)?
Offer a terse response. 1.02. What is the ratio of the Gross enrolment ratio (%) of Primary schools in High income: nonOECD to that in Latin America(all income levels)?
Provide a short and direct response. 0.88. What is the ratio of the Gross enrolment ratio (%) in Secondary schools in High income: nonOECD to that in Latin America(all income levels)?
Offer a terse response. 1.02. What is the ratio of the Gross enrolment ratio (%) of Tertiary schools in High income: nonOECD to that in Latin America(all income levels)?
Provide a short and direct response. 2.22. What is the ratio of the Gross enrolment ratio (%) in Pre-primary schools in High income: OECD to that in Latin America(all income levels)?
Provide a succinct answer. 1.33. What is the ratio of the Gross enrolment ratio (%) of Primary schools in High income: OECD to that in Latin America(all income levels)?
Your response must be concise. 0.88. What is the ratio of the Gross enrolment ratio (%) of Secondary schools in High income: OECD to that in Latin America(all income levels)?
Make the answer very short. 1.18. What is the ratio of the Gross enrolment ratio (%) in Tertiary schools in High income: OECD to that in Latin America(all income levels)?
Your answer should be very brief. 2.43. What is the difference between the highest and the second highest Gross enrolment ratio (%) of Pre-primary schools?
Offer a terse response. 5.1. What is the difference between the highest and the second highest Gross enrolment ratio (%) in Primary schools?
Your answer should be compact. 13.68. What is the difference between the highest and the second highest Gross enrolment ratio (%) of Secondary schools?
Make the answer very short. 3.65. What is the difference between the highest and the second highest Gross enrolment ratio (%) in Tertiary schools?
Offer a terse response. 1.38. What is the difference between the highest and the lowest Gross enrolment ratio (%) in Pre-primary schools?
Offer a terse response. 71.68. What is the difference between the highest and the lowest Gross enrolment ratio (%) in Primary schools?
Provide a succinct answer. 46.18. What is the difference between the highest and the lowest Gross enrolment ratio (%) in Secondary schools?
Your response must be concise. 82.28. What is the difference between the highest and the lowest Gross enrolment ratio (%) in Tertiary schools?
Provide a short and direct response. 60.73. 